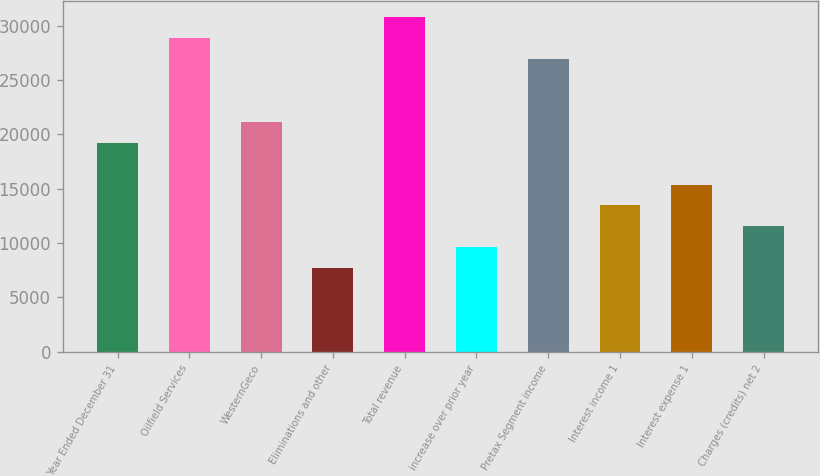Convert chart to OTSL. <chart><loc_0><loc_0><loc_500><loc_500><bar_chart><fcel>Year Ended December 31<fcel>Oilfield Services<fcel>WesternGeco<fcel>Eliminations and other<fcel>Total revenue<fcel>increase over prior year<fcel>Pretax Segment income<fcel>Interest income 1<fcel>Interest expense 1<fcel>Charges (credits) net 2<nl><fcel>19230<fcel>28844.8<fcel>21153<fcel>7692.3<fcel>30767.7<fcel>9615.25<fcel>26921.8<fcel>13461.1<fcel>15384.1<fcel>11538.2<nl></chart> 